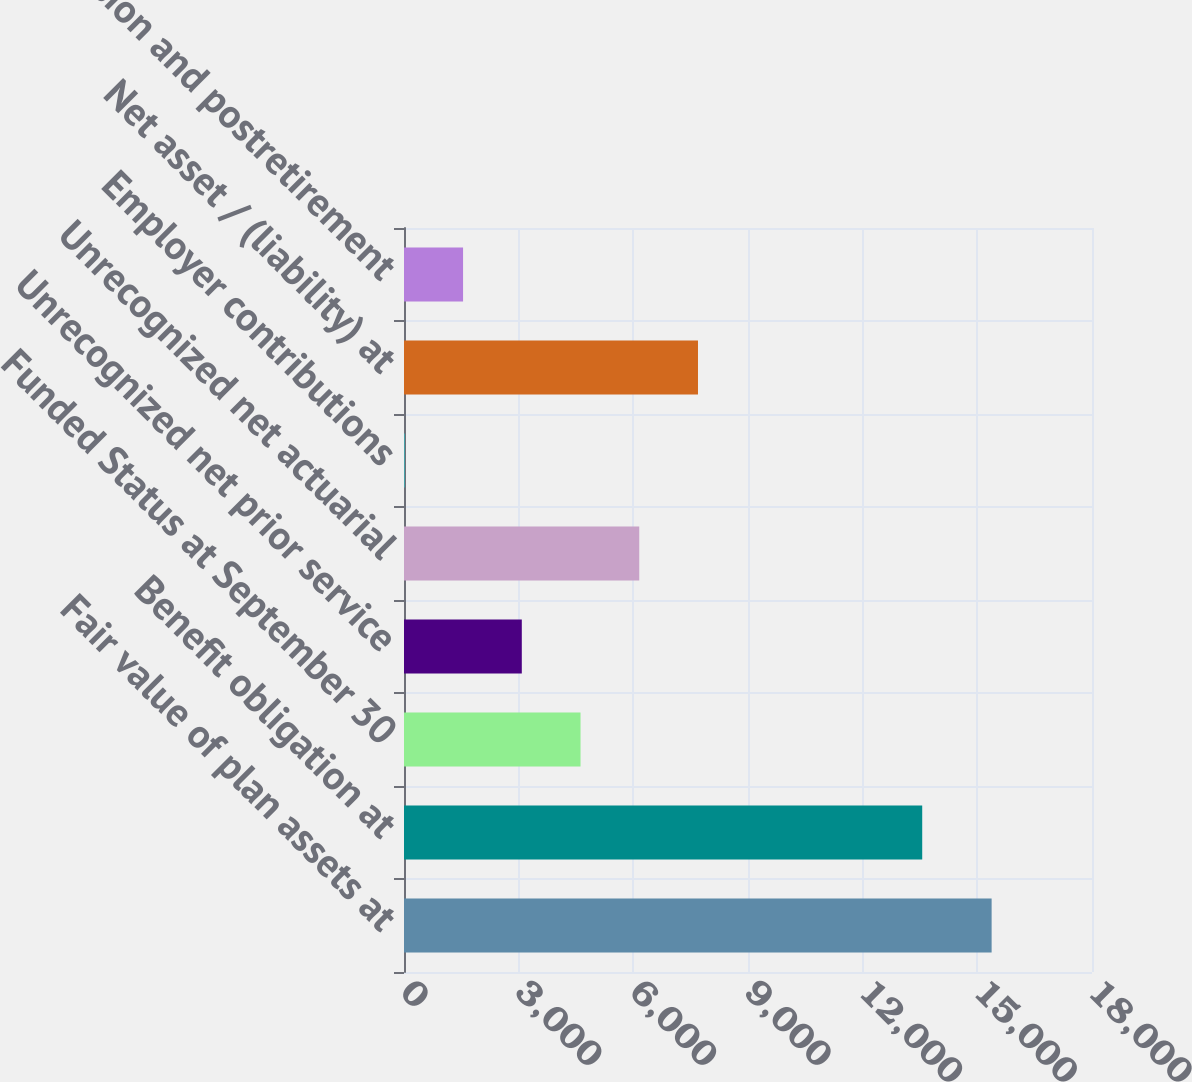<chart> <loc_0><loc_0><loc_500><loc_500><bar_chart><fcel>Fair value of plan assets at<fcel>Benefit obligation at<fcel>Funded Status at September 30<fcel>Unrecognized net prior service<fcel>Unrecognized net actuarial<fcel>Employer contributions<fcel>Net asset / (liability) at<fcel>Pension and postretirement<nl><fcel>15374<fcel>13558<fcel>4618.5<fcel>3082<fcel>6155<fcel>9<fcel>7691.5<fcel>1545.5<nl></chart> 